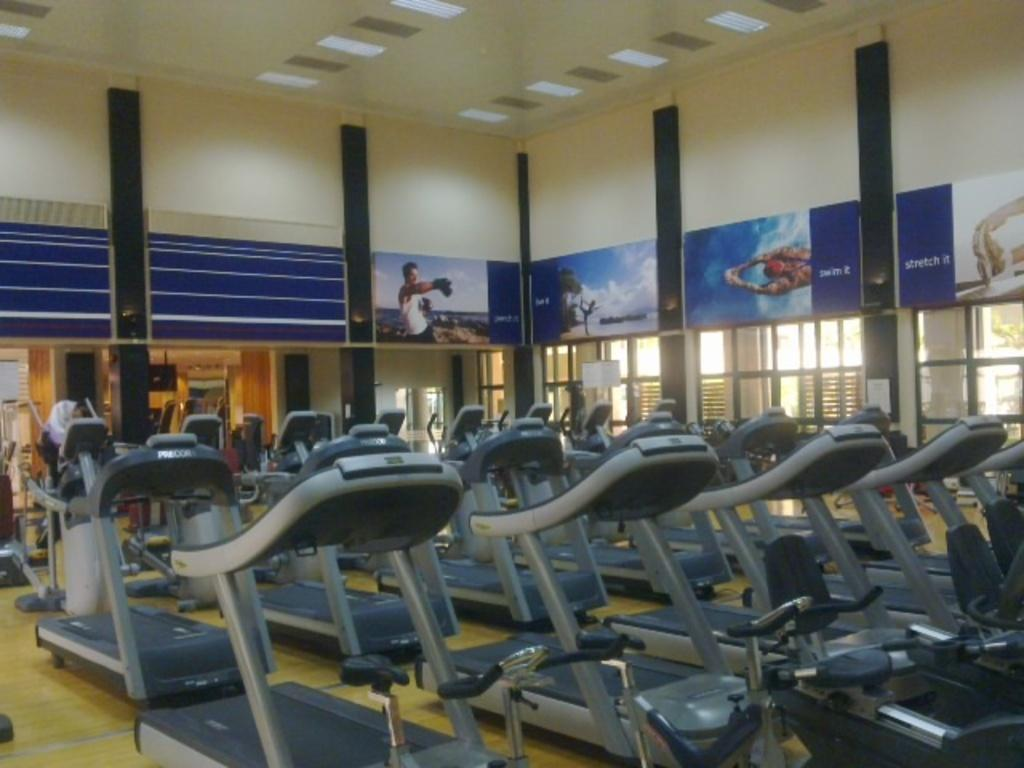What type of exercise equipment is visible in the image? There are treadmills in the image. How are the treadmills positioned in the image? The treadmills are placed on the floor. Is anyone using the treadmills in the image? Yes, there is a person on a treadmill in the image. What can be seen on the wall in the image? There is a wall with pictures in the image. What architectural features are present in the image? There are pillars in the image. What is above the treadmills in the image? There is a roof in the image. What type of engine is powering the treadmills in the image? There is no engine present in the image; the treadmills are powered by electricity or manually operated. Can you see a pig in the image? No, there is no pig present in the image. 